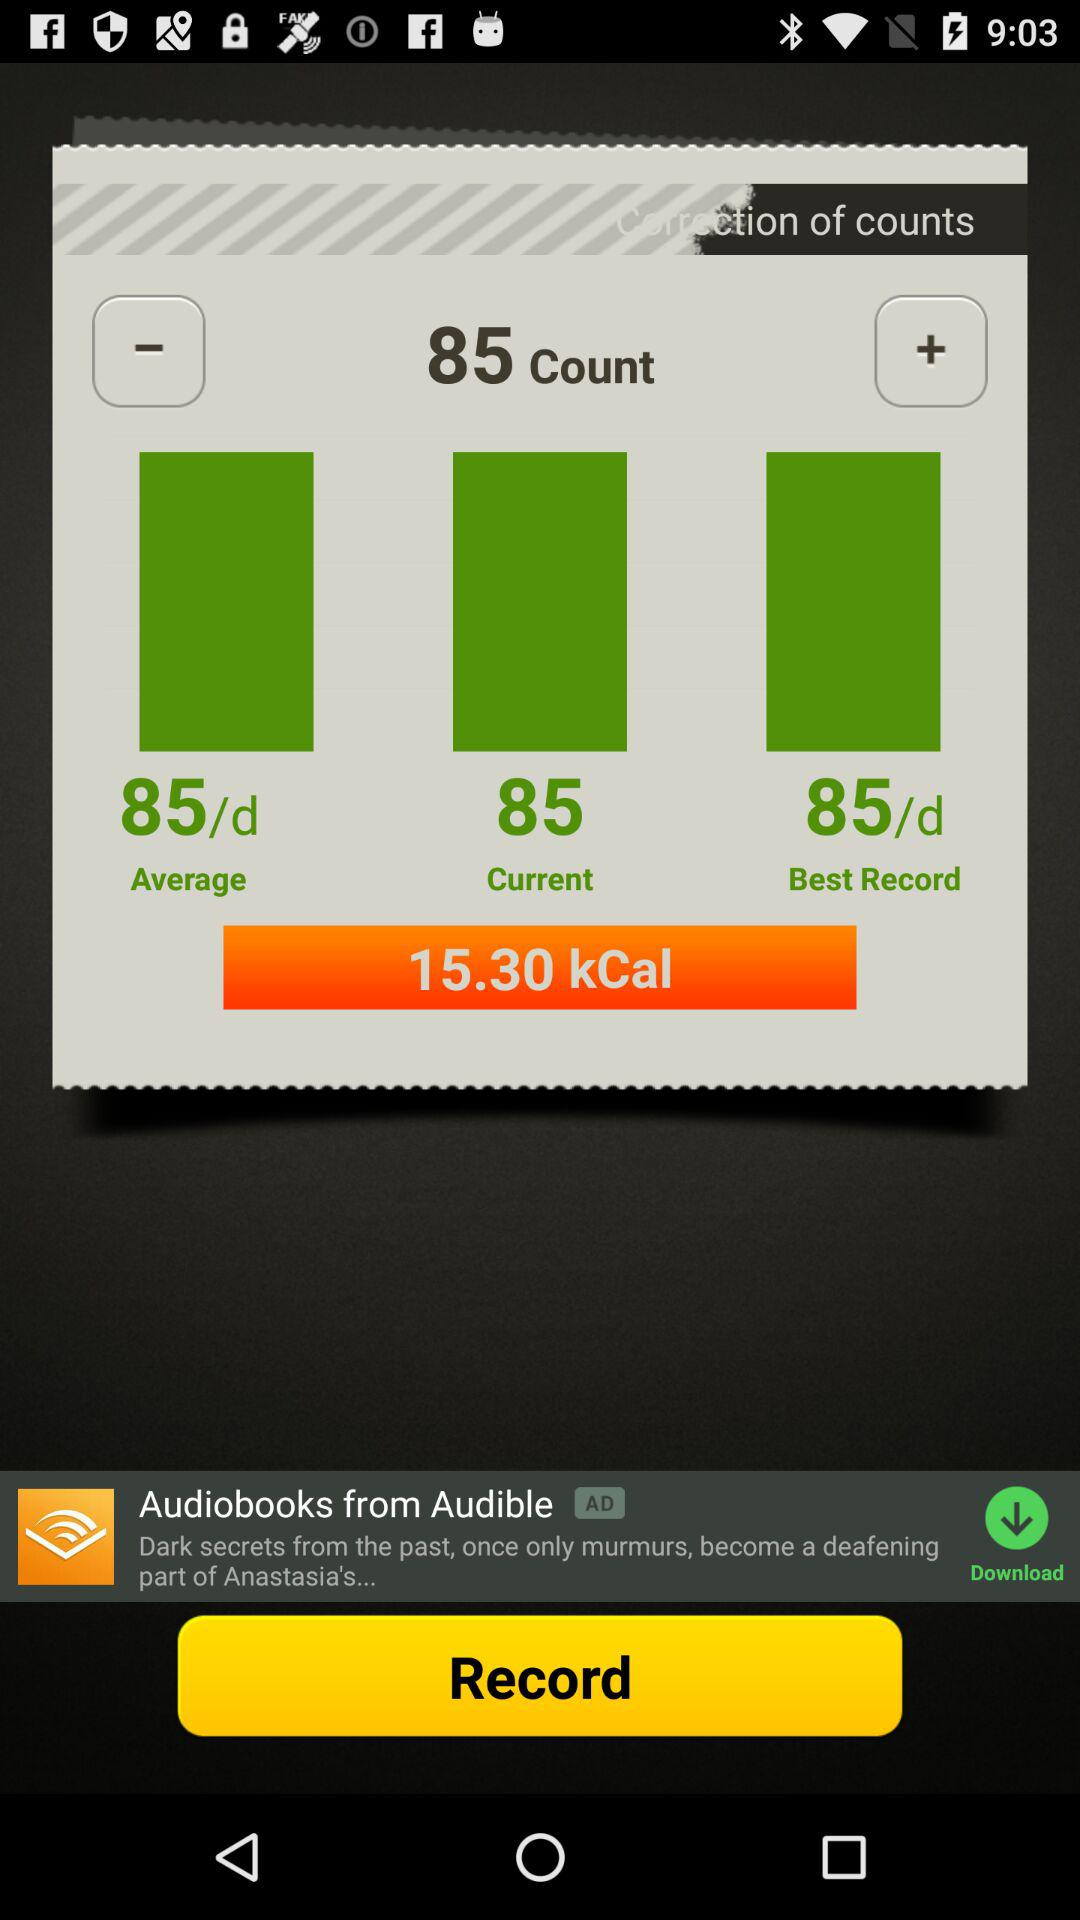What is the average count? The average count is 85/d. 